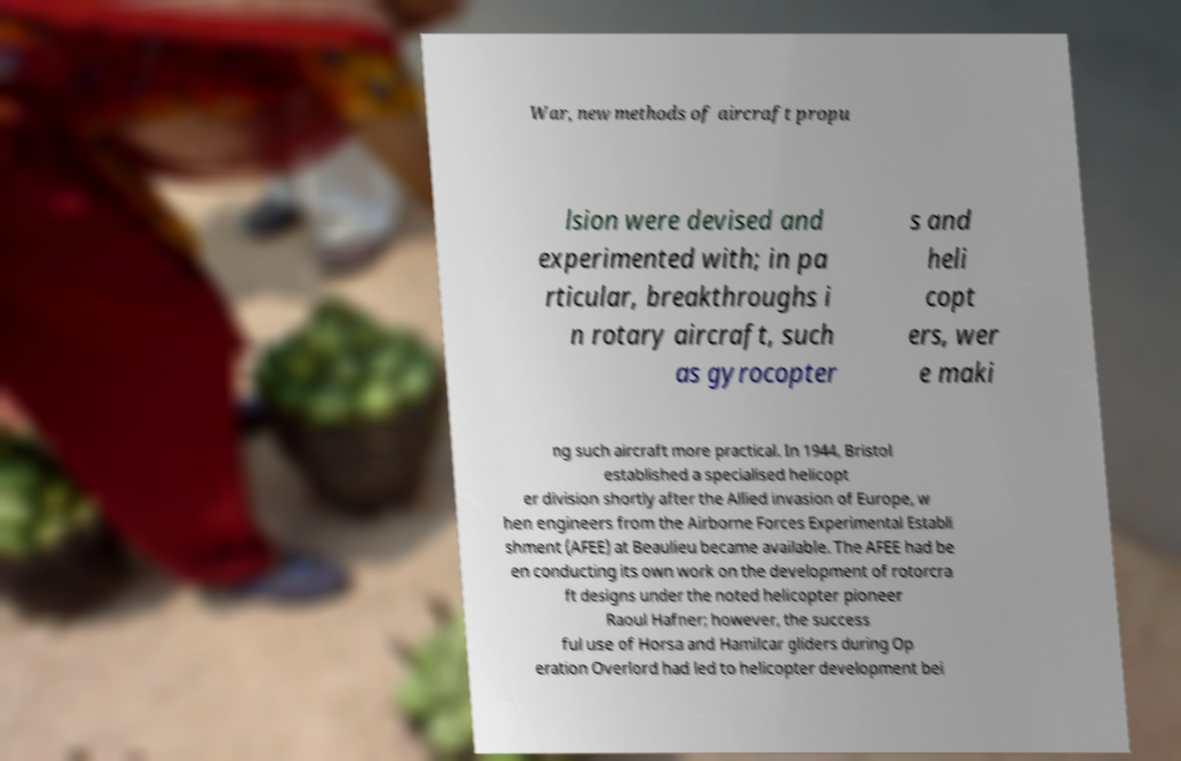Can you accurately transcribe the text from the provided image for me? War, new methods of aircraft propu lsion were devised and experimented with; in pa rticular, breakthroughs i n rotary aircraft, such as gyrocopter s and heli copt ers, wer e maki ng such aircraft more practical. In 1944, Bristol established a specialised helicopt er division shortly after the Allied invasion of Europe, w hen engineers from the Airborne Forces Experimental Establi shment (AFEE) at Beaulieu became available. The AFEE had be en conducting its own work on the development of rotorcra ft designs under the noted helicopter pioneer Raoul Hafner; however, the success ful use of Horsa and Hamilcar gliders during Op eration Overlord had led to helicopter development bei 